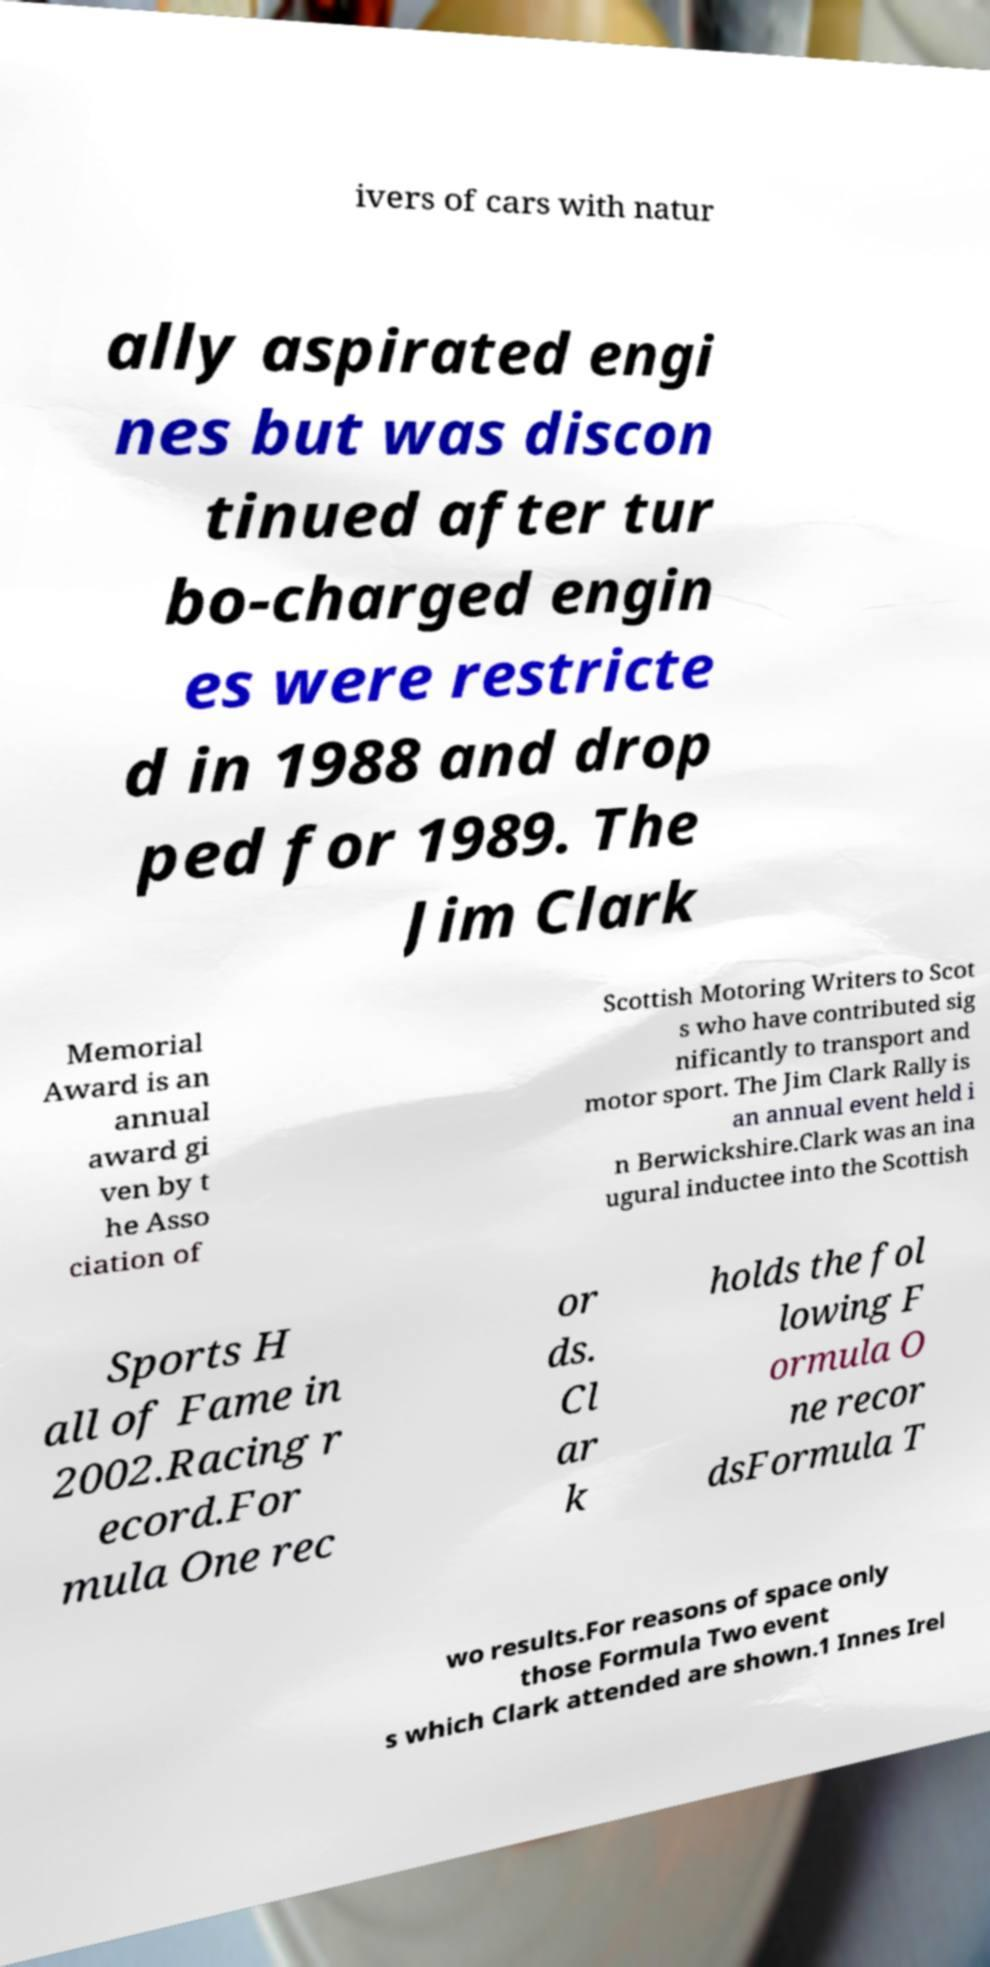I need the written content from this picture converted into text. Can you do that? ivers of cars with natur ally aspirated engi nes but was discon tinued after tur bo-charged engin es were restricte d in 1988 and drop ped for 1989. The Jim Clark Memorial Award is an annual award gi ven by t he Asso ciation of Scottish Motoring Writers to Scot s who have contributed sig nificantly to transport and motor sport. The Jim Clark Rally is an annual event held i n Berwickshire.Clark was an ina ugural inductee into the Scottish Sports H all of Fame in 2002.Racing r ecord.For mula One rec or ds. Cl ar k holds the fol lowing F ormula O ne recor dsFormula T wo results.For reasons of space only those Formula Two event s which Clark attended are shown.1 Innes Irel 